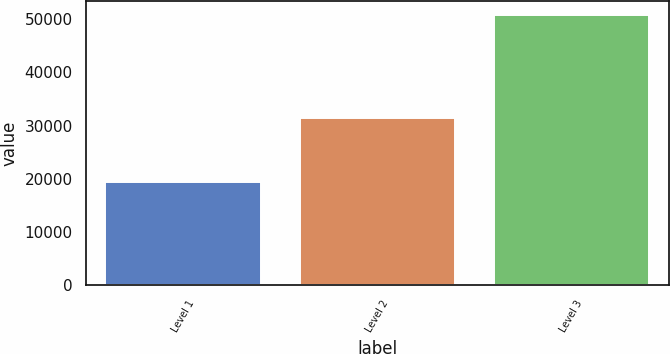<chart> <loc_0><loc_0><loc_500><loc_500><bar_chart><fcel>Level 1<fcel>Level 2<fcel>Level 3<nl><fcel>19416<fcel>31389<fcel>50805<nl></chart> 